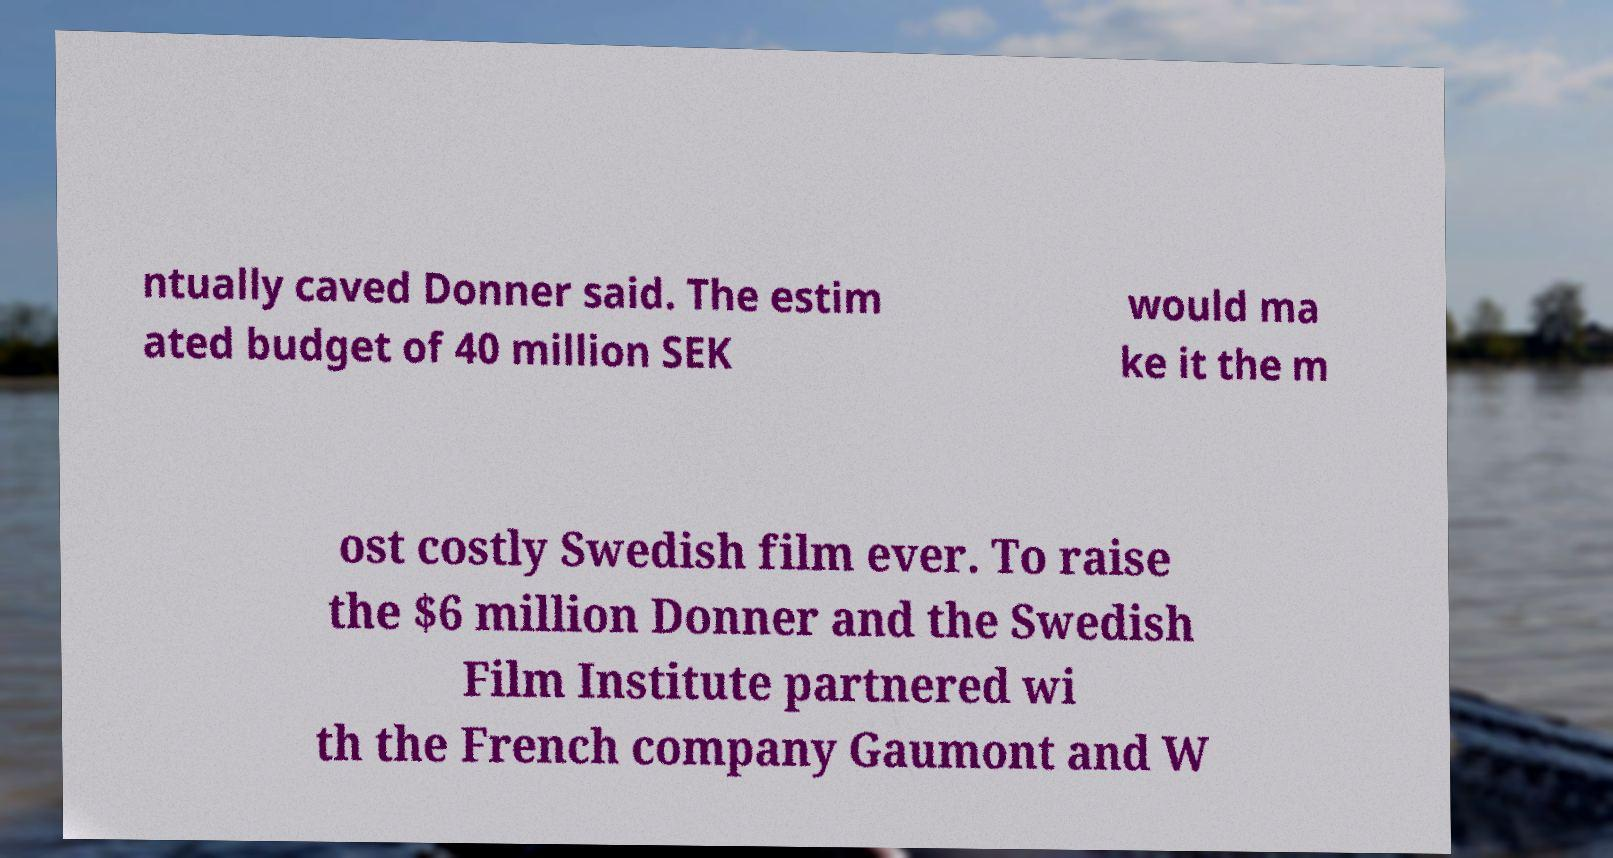Can you accurately transcribe the text from the provided image for me? ntually caved Donner said. The estim ated budget of 40 million SEK would ma ke it the m ost costly Swedish film ever. To raise the $6 million Donner and the Swedish Film Institute partnered wi th the French company Gaumont and W 